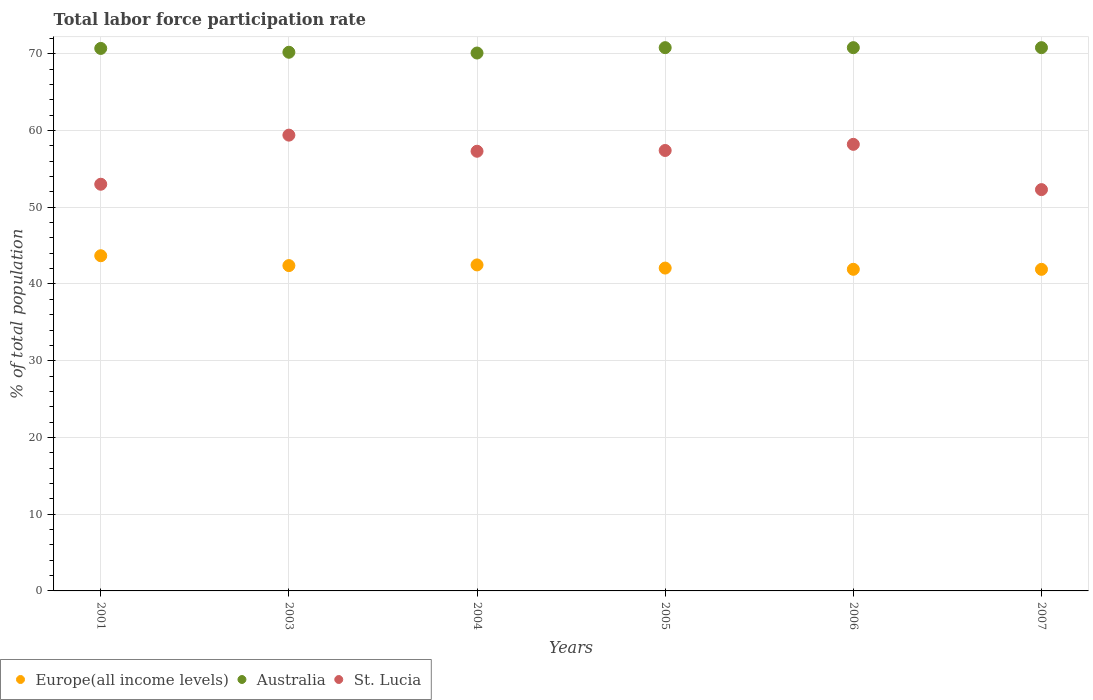How many different coloured dotlines are there?
Your answer should be very brief. 3. What is the total labor force participation rate in Europe(all income levels) in 2001?
Ensure brevity in your answer.  43.68. Across all years, what is the maximum total labor force participation rate in St. Lucia?
Offer a very short reply. 59.4. Across all years, what is the minimum total labor force participation rate in St. Lucia?
Make the answer very short. 52.3. In which year was the total labor force participation rate in Europe(all income levels) maximum?
Give a very brief answer. 2001. What is the total total labor force participation rate in Europe(all income levels) in the graph?
Keep it short and to the point. 254.47. What is the difference between the total labor force participation rate in Australia in 2006 and the total labor force participation rate in Europe(all income levels) in 2003?
Give a very brief answer. 28.4. What is the average total labor force participation rate in Australia per year?
Your answer should be very brief. 70.57. In the year 2001, what is the difference between the total labor force participation rate in Australia and total labor force participation rate in Europe(all income levels)?
Ensure brevity in your answer.  27.02. What is the ratio of the total labor force participation rate in Europe(all income levels) in 2003 to that in 2004?
Your response must be concise. 1. Is the total labor force participation rate in Europe(all income levels) in 2005 less than that in 2007?
Make the answer very short. No. Is the difference between the total labor force participation rate in Australia in 2005 and 2007 greater than the difference between the total labor force participation rate in Europe(all income levels) in 2005 and 2007?
Provide a succinct answer. No. What is the difference between the highest and the lowest total labor force participation rate in Europe(all income levels)?
Provide a short and direct response. 1.77. Does the total labor force participation rate in Europe(all income levels) monotonically increase over the years?
Your response must be concise. No. Is the total labor force participation rate in Australia strictly greater than the total labor force participation rate in St. Lucia over the years?
Offer a terse response. Yes. How many years are there in the graph?
Your answer should be very brief. 6. Does the graph contain grids?
Your answer should be compact. Yes. Where does the legend appear in the graph?
Provide a short and direct response. Bottom left. What is the title of the graph?
Provide a short and direct response. Total labor force participation rate. Does "Maldives" appear as one of the legend labels in the graph?
Keep it short and to the point. No. What is the label or title of the X-axis?
Offer a very short reply. Years. What is the label or title of the Y-axis?
Ensure brevity in your answer.  % of total population. What is the % of total population in Europe(all income levels) in 2001?
Ensure brevity in your answer.  43.68. What is the % of total population in Australia in 2001?
Your response must be concise. 70.7. What is the % of total population in St. Lucia in 2001?
Keep it short and to the point. 53. What is the % of total population of Europe(all income levels) in 2003?
Offer a terse response. 42.4. What is the % of total population in Australia in 2003?
Offer a very short reply. 70.2. What is the % of total population of St. Lucia in 2003?
Offer a terse response. 59.4. What is the % of total population in Europe(all income levels) in 2004?
Your answer should be compact. 42.49. What is the % of total population in Australia in 2004?
Your answer should be compact. 70.1. What is the % of total population of St. Lucia in 2004?
Keep it short and to the point. 57.3. What is the % of total population in Europe(all income levels) in 2005?
Provide a succinct answer. 42.07. What is the % of total population of Australia in 2005?
Ensure brevity in your answer.  70.8. What is the % of total population in St. Lucia in 2005?
Give a very brief answer. 57.4. What is the % of total population of Europe(all income levels) in 2006?
Keep it short and to the point. 41.92. What is the % of total population of Australia in 2006?
Your answer should be compact. 70.8. What is the % of total population of St. Lucia in 2006?
Your response must be concise. 58.2. What is the % of total population of Europe(all income levels) in 2007?
Provide a short and direct response. 41.91. What is the % of total population of Australia in 2007?
Offer a very short reply. 70.8. What is the % of total population of St. Lucia in 2007?
Make the answer very short. 52.3. Across all years, what is the maximum % of total population in Europe(all income levels)?
Your answer should be very brief. 43.68. Across all years, what is the maximum % of total population of Australia?
Your response must be concise. 70.8. Across all years, what is the maximum % of total population in St. Lucia?
Keep it short and to the point. 59.4. Across all years, what is the minimum % of total population of Europe(all income levels)?
Give a very brief answer. 41.91. Across all years, what is the minimum % of total population of Australia?
Your answer should be compact. 70.1. Across all years, what is the minimum % of total population in St. Lucia?
Provide a succinct answer. 52.3. What is the total % of total population in Europe(all income levels) in the graph?
Your answer should be compact. 254.47. What is the total % of total population in Australia in the graph?
Ensure brevity in your answer.  423.4. What is the total % of total population of St. Lucia in the graph?
Make the answer very short. 337.6. What is the difference between the % of total population in Europe(all income levels) in 2001 and that in 2003?
Make the answer very short. 1.28. What is the difference between the % of total population in St. Lucia in 2001 and that in 2003?
Offer a very short reply. -6.4. What is the difference between the % of total population in Europe(all income levels) in 2001 and that in 2004?
Provide a short and direct response. 1.2. What is the difference between the % of total population of Australia in 2001 and that in 2004?
Offer a very short reply. 0.6. What is the difference between the % of total population in Europe(all income levels) in 2001 and that in 2005?
Provide a succinct answer. 1.61. What is the difference between the % of total population in Australia in 2001 and that in 2005?
Give a very brief answer. -0.1. What is the difference between the % of total population of Europe(all income levels) in 2001 and that in 2006?
Your answer should be compact. 1.77. What is the difference between the % of total population of Australia in 2001 and that in 2006?
Your response must be concise. -0.1. What is the difference between the % of total population of St. Lucia in 2001 and that in 2006?
Your response must be concise. -5.2. What is the difference between the % of total population in Europe(all income levels) in 2001 and that in 2007?
Provide a succinct answer. 1.77. What is the difference between the % of total population in Australia in 2001 and that in 2007?
Provide a short and direct response. -0.1. What is the difference between the % of total population of St. Lucia in 2001 and that in 2007?
Give a very brief answer. 0.7. What is the difference between the % of total population of Europe(all income levels) in 2003 and that in 2004?
Give a very brief answer. -0.09. What is the difference between the % of total population of St. Lucia in 2003 and that in 2004?
Offer a very short reply. 2.1. What is the difference between the % of total population in Europe(all income levels) in 2003 and that in 2005?
Your response must be concise. 0.32. What is the difference between the % of total population in Australia in 2003 and that in 2005?
Provide a short and direct response. -0.6. What is the difference between the % of total population of Europe(all income levels) in 2003 and that in 2006?
Offer a terse response. 0.48. What is the difference between the % of total population in Europe(all income levels) in 2003 and that in 2007?
Make the answer very short. 0.49. What is the difference between the % of total population of Australia in 2003 and that in 2007?
Offer a very short reply. -0.6. What is the difference between the % of total population of St. Lucia in 2003 and that in 2007?
Offer a very short reply. 7.1. What is the difference between the % of total population in Europe(all income levels) in 2004 and that in 2005?
Offer a very short reply. 0.41. What is the difference between the % of total population of Australia in 2004 and that in 2005?
Give a very brief answer. -0.7. What is the difference between the % of total population of St. Lucia in 2004 and that in 2005?
Offer a very short reply. -0.1. What is the difference between the % of total population in Europe(all income levels) in 2004 and that in 2006?
Make the answer very short. 0.57. What is the difference between the % of total population of Australia in 2004 and that in 2006?
Offer a terse response. -0.7. What is the difference between the % of total population of Europe(all income levels) in 2004 and that in 2007?
Keep it short and to the point. 0.58. What is the difference between the % of total population in Australia in 2004 and that in 2007?
Offer a very short reply. -0.7. What is the difference between the % of total population of St. Lucia in 2004 and that in 2007?
Your answer should be compact. 5. What is the difference between the % of total population in Europe(all income levels) in 2005 and that in 2006?
Give a very brief answer. 0.16. What is the difference between the % of total population of Australia in 2005 and that in 2006?
Your answer should be very brief. 0. What is the difference between the % of total population in Europe(all income levels) in 2005 and that in 2007?
Keep it short and to the point. 0.16. What is the difference between the % of total population in Australia in 2005 and that in 2007?
Keep it short and to the point. 0. What is the difference between the % of total population of Europe(all income levels) in 2006 and that in 2007?
Your response must be concise. 0.01. What is the difference between the % of total population in St. Lucia in 2006 and that in 2007?
Provide a succinct answer. 5.9. What is the difference between the % of total population of Europe(all income levels) in 2001 and the % of total population of Australia in 2003?
Provide a short and direct response. -26.52. What is the difference between the % of total population in Europe(all income levels) in 2001 and the % of total population in St. Lucia in 2003?
Offer a very short reply. -15.72. What is the difference between the % of total population in Europe(all income levels) in 2001 and the % of total population in Australia in 2004?
Keep it short and to the point. -26.42. What is the difference between the % of total population of Europe(all income levels) in 2001 and the % of total population of St. Lucia in 2004?
Keep it short and to the point. -13.62. What is the difference between the % of total population in Europe(all income levels) in 2001 and the % of total population in Australia in 2005?
Keep it short and to the point. -27.12. What is the difference between the % of total population of Europe(all income levels) in 2001 and the % of total population of St. Lucia in 2005?
Your answer should be compact. -13.72. What is the difference between the % of total population of Australia in 2001 and the % of total population of St. Lucia in 2005?
Offer a terse response. 13.3. What is the difference between the % of total population of Europe(all income levels) in 2001 and the % of total population of Australia in 2006?
Your answer should be compact. -27.12. What is the difference between the % of total population in Europe(all income levels) in 2001 and the % of total population in St. Lucia in 2006?
Provide a short and direct response. -14.52. What is the difference between the % of total population of Europe(all income levels) in 2001 and the % of total population of Australia in 2007?
Ensure brevity in your answer.  -27.12. What is the difference between the % of total population of Europe(all income levels) in 2001 and the % of total population of St. Lucia in 2007?
Your response must be concise. -8.62. What is the difference between the % of total population in Europe(all income levels) in 2003 and the % of total population in Australia in 2004?
Provide a short and direct response. -27.7. What is the difference between the % of total population of Europe(all income levels) in 2003 and the % of total population of St. Lucia in 2004?
Make the answer very short. -14.9. What is the difference between the % of total population in Europe(all income levels) in 2003 and the % of total population in Australia in 2005?
Offer a very short reply. -28.4. What is the difference between the % of total population of Europe(all income levels) in 2003 and the % of total population of St. Lucia in 2005?
Your answer should be very brief. -15. What is the difference between the % of total population in Australia in 2003 and the % of total population in St. Lucia in 2005?
Ensure brevity in your answer.  12.8. What is the difference between the % of total population of Europe(all income levels) in 2003 and the % of total population of Australia in 2006?
Keep it short and to the point. -28.4. What is the difference between the % of total population of Europe(all income levels) in 2003 and the % of total population of St. Lucia in 2006?
Give a very brief answer. -15.8. What is the difference between the % of total population of Europe(all income levels) in 2003 and the % of total population of Australia in 2007?
Offer a terse response. -28.4. What is the difference between the % of total population of Europe(all income levels) in 2003 and the % of total population of St. Lucia in 2007?
Keep it short and to the point. -9.9. What is the difference between the % of total population in Australia in 2003 and the % of total population in St. Lucia in 2007?
Your answer should be compact. 17.9. What is the difference between the % of total population in Europe(all income levels) in 2004 and the % of total population in Australia in 2005?
Your answer should be very brief. -28.31. What is the difference between the % of total population in Europe(all income levels) in 2004 and the % of total population in St. Lucia in 2005?
Offer a very short reply. -14.91. What is the difference between the % of total population of Australia in 2004 and the % of total population of St. Lucia in 2005?
Provide a succinct answer. 12.7. What is the difference between the % of total population in Europe(all income levels) in 2004 and the % of total population in Australia in 2006?
Offer a very short reply. -28.31. What is the difference between the % of total population of Europe(all income levels) in 2004 and the % of total population of St. Lucia in 2006?
Ensure brevity in your answer.  -15.71. What is the difference between the % of total population in Europe(all income levels) in 2004 and the % of total population in Australia in 2007?
Your answer should be compact. -28.31. What is the difference between the % of total population in Europe(all income levels) in 2004 and the % of total population in St. Lucia in 2007?
Provide a succinct answer. -9.81. What is the difference between the % of total population of Australia in 2004 and the % of total population of St. Lucia in 2007?
Your answer should be compact. 17.8. What is the difference between the % of total population in Europe(all income levels) in 2005 and the % of total population in Australia in 2006?
Provide a succinct answer. -28.73. What is the difference between the % of total population in Europe(all income levels) in 2005 and the % of total population in St. Lucia in 2006?
Provide a succinct answer. -16.13. What is the difference between the % of total population in Australia in 2005 and the % of total population in St. Lucia in 2006?
Provide a short and direct response. 12.6. What is the difference between the % of total population in Europe(all income levels) in 2005 and the % of total population in Australia in 2007?
Your answer should be very brief. -28.73. What is the difference between the % of total population of Europe(all income levels) in 2005 and the % of total population of St. Lucia in 2007?
Your response must be concise. -10.23. What is the difference between the % of total population of Europe(all income levels) in 2006 and the % of total population of Australia in 2007?
Offer a terse response. -28.88. What is the difference between the % of total population of Europe(all income levels) in 2006 and the % of total population of St. Lucia in 2007?
Ensure brevity in your answer.  -10.38. What is the average % of total population of Europe(all income levels) per year?
Give a very brief answer. 42.41. What is the average % of total population of Australia per year?
Give a very brief answer. 70.57. What is the average % of total population of St. Lucia per year?
Provide a short and direct response. 56.27. In the year 2001, what is the difference between the % of total population in Europe(all income levels) and % of total population in Australia?
Ensure brevity in your answer.  -27.02. In the year 2001, what is the difference between the % of total population of Europe(all income levels) and % of total population of St. Lucia?
Your answer should be very brief. -9.32. In the year 2003, what is the difference between the % of total population of Europe(all income levels) and % of total population of Australia?
Make the answer very short. -27.8. In the year 2003, what is the difference between the % of total population in Europe(all income levels) and % of total population in St. Lucia?
Offer a very short reply. -17. In the year 2003, what is the difference between the % of total population in Australia and % of total population in St. Lucia?
Offer a terse response. 10.8. In the year 2004, what is the difference between the % of total population of Europe(all income levels) and % of total population of Australia?
Keep it short and to the point. -27.61. In the year 2004, what is the difference between the % of total population of Europe(all income levels) and % of total population of St. Lucia?
Your response must be concise. -14.81. In the year 2005, what is the difference between the % of total population of Europe(all income levels) and % of total population of Australia?
Make the answer very short. -28.73. In the year 2005, what is the difference between the % of total population of Europe(all income levels) and % of total population of St. Lucia?
Provide a succinct answer. -15.33. In the year 2005, what is the difference between the % of total population in Australia and % of total population in St. Lucia?
Your answer should be very brief. 13.4. In the year 2006, what is the difference between the % of total population of Europe(all income levels) and % of total population of Australia?
Give a very brief answer. -28.88. In the year 2006, what is the difference between the % of total population in Europe(all income levels) and % of total population in St. Lucia?
Offer a very short reply. -16.28. In the year 2006, what is the difference between the % of total population of Australia and % of total population of St. Lucia?
Your answer should be compact. 12.6. In the year 2007, what is the difference between the % of total population of Europe(all income levels) and % of total population of Australia?
Offer a terse response. -28.89. In the year 2007, what is the difference between the % of total population in Europe(all income levels) and % of total population in St. Lucia?
Make the answer very short. -10.39. What is the ratio of the % of total population of Europe(all income levels) in 2001 to that in 2003?
Provide a succinct answer. 1.03. What is the ratio of the % of total population of Australia in 2001 to that in 2003?
Offer a terse response. 1.01. What is the ratio of the % of total population in St. Lucia in 2001 to that in 2003?
Your answer should be very brief. 0.89. What is the ratio of the % of total population in Europe(all income levels) in 2001 to that in 2004?
Keep it short and to the point. 1.03. What is the ratio of the % of total population in Australia in 2001 to that in 2004?
Offer a terse response. 1.01. What is the ratio of the % of total population of St. Lucia in 2001 to that in 2004?
Your response must be concise. 0.93. What is the ratio of the % of total population in Europe(all income levels) in 2001 to that in 2005?
Make the answer very short. 1.04. What is the ratio of the % of total population in Australia in 2001 to that in 2005?
Offer a very short reply. 1. What is the ratio of the % of total population in St. Lucia in 2001 to that in 2005?
Keep it short and to the point. 0.92. What is the ratio of the % of total population in Europe(all income levels) in 2001 to that in 2006?
Make the answer very short. 1.04. What is the ratio of the % of total population in Australia in 2001 to that in 2006?
Provide a succinct answer. 1. What is the ratio of the % of total population of St. Lucia in 2001 to that in 2006?
Provide a short and direct response. 0.91. What is the ratio of the % of total population of Europe(all income levels) in 2001 to that in 2007?
Offer a very short reply. 1.04. What is the ratio of the % of total population in St. Lucia in 2001 to that in 2007?
Your response must be concise. 1.01. What is the ratio of the % of total population of Australia in 2003 to that in 2004?
Provide a succinct answer. 1. What is the ratio of the % of total population in St. Lucia in 2003 to that in 2004?
Your answer should be compact. 1.04. What is the ratio of the % of total population in Europe(all income levels) in 2003 to that in 2005?
Give a very brief answer. 1.01. What is the ratio of the % of total population in Australia in 2003 to that in 2005?
Offer a terse response. 0.99. What is the ratio of the % of total population in St. Lucia in 2003 to that in 2005?
Provide a short and direct response. 1.03. What is the ratio of the % of total population in Europe(all income levels) in 2003 to that in 2006?
Make the answer very short. 1.01. What is the ratio of the % of total population of Australia in 2003 to that in 2006?
Provide a short and direct response. 0.99. What is the ratio of the % of total population in St. Lucia in 2003 to that in 2006?
Make the answer very short. 1.02. What is the ratio of the % of total population of Europe(all income levels) in 2003 to that in 2007?
Give a very brief answer. 1.01. What is the ratio of the % of total population in St. Lucia in 2003 to that in 2007?
Provide a succinct answer. 1.14. What is the ratio of the % of total population of Europe(all income levels) in 2004 to that in 2005?
Give a very brief answer. 1.01. What is the ratio of the % of total population in Europe(all income levels) in 2004 to that in 2006?
Your response must be concise. 1.01. What is the ratio of the % of total population in St. Lucia in 2004 to that in 2006?
Your answer should be very brief. 0.98. What is the ratio of the % of total population in Europe(all income levels) in 2004 to that in 2007?
Your answer should be very brief. 1.01. What is the ratio of the % of total population of Australia in 2004 to that in 2007?
Make the answer very short. 0.99. What is the ratio of the % of total population in St. Lucia in 2004 to that in 2007?
Offer a very short reply. 1.1. What is the ratio of the % of total population in Australia in 2005 to that in 2006?
Offer a very short reply. 1. What is the ratio of the % of total population of St. Lucia in 2005 to that in 2006?
Your answer should be compact. 0.99. What is the ratio of the % of total population of St. Lucia in 2005 to that in 2007?
Provide a succinct answer. 1.1. What is the ratio of the % of total population of St. Lucia in 2006 to that in 2007?
Keep it short and to the point. 1.11. What is the difference between the highest and the second highest % of total population in Europe(all income levels)?
Offer a very short reply. 1.2. What is the difference between the highest and the second highest % of total population of Australia?
Your response must be concise. 0. What is the difference between the highest and the second highest % of total population in St. Lucia?
Provide a short and direct response. 1.2. What is the difference between the highest and the lowest % of total population in Europe(all income levels)?
Provide a succinct answer. 1.77. What is the difference between the highest and the lowest % of total population in St. Lucia?
Ensure brevity in your answer.  7.1. 